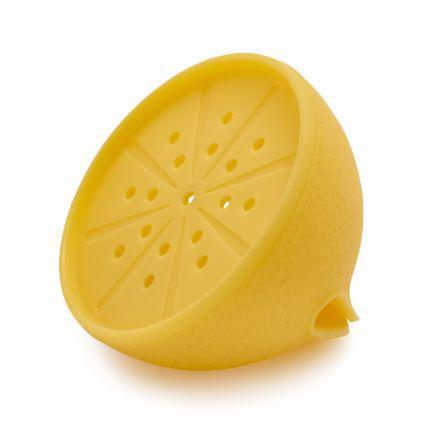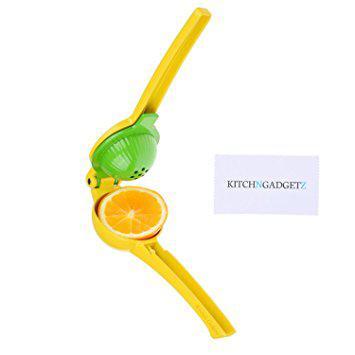The first image is the image on the left, the second image is the image on the right. Evaluate the accuracy of this statement regarding the images: "One image shows a half of an orange-fleshed citrus and a tool with a handle, and the other image shows an incomplete lemon shape.". Is it true? Answer yes or no. Yes. The first image is the image on the left, the second image is the image on the right. For the images displayed, is the sentence "In at least one image there are two halves of a lemon." factually correct? Answer yes or no. No. 